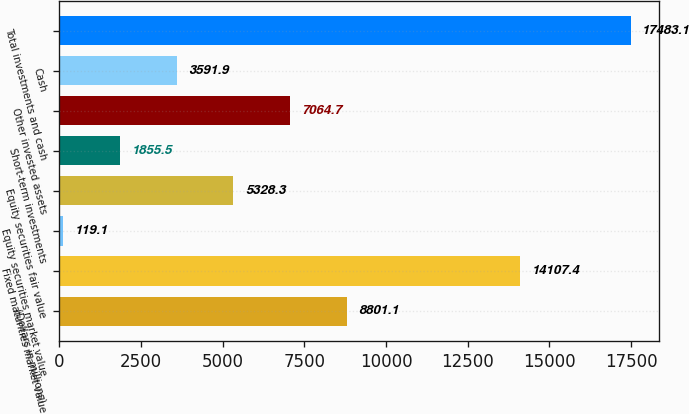Convert chart. <chart><loc_0><loc_0><loc_500><loc_500><bar_chart><fcel>(Dollars in millions)<fcel>Fixed maturities market value<fcel>Equity securities market value<fcel>Equity securities fair value<fcel>Short-term investments<fcel>Other invested assets<fcel>Cash<fcel>Total investments and cash<nl><fcel>8801.1<fcel>14107.4<fcel>119.1<fcel>5328.3<fcel>1855.5<fcel>7064.7<fcel>3591.9<fcel>17483.1<nl></chart> 